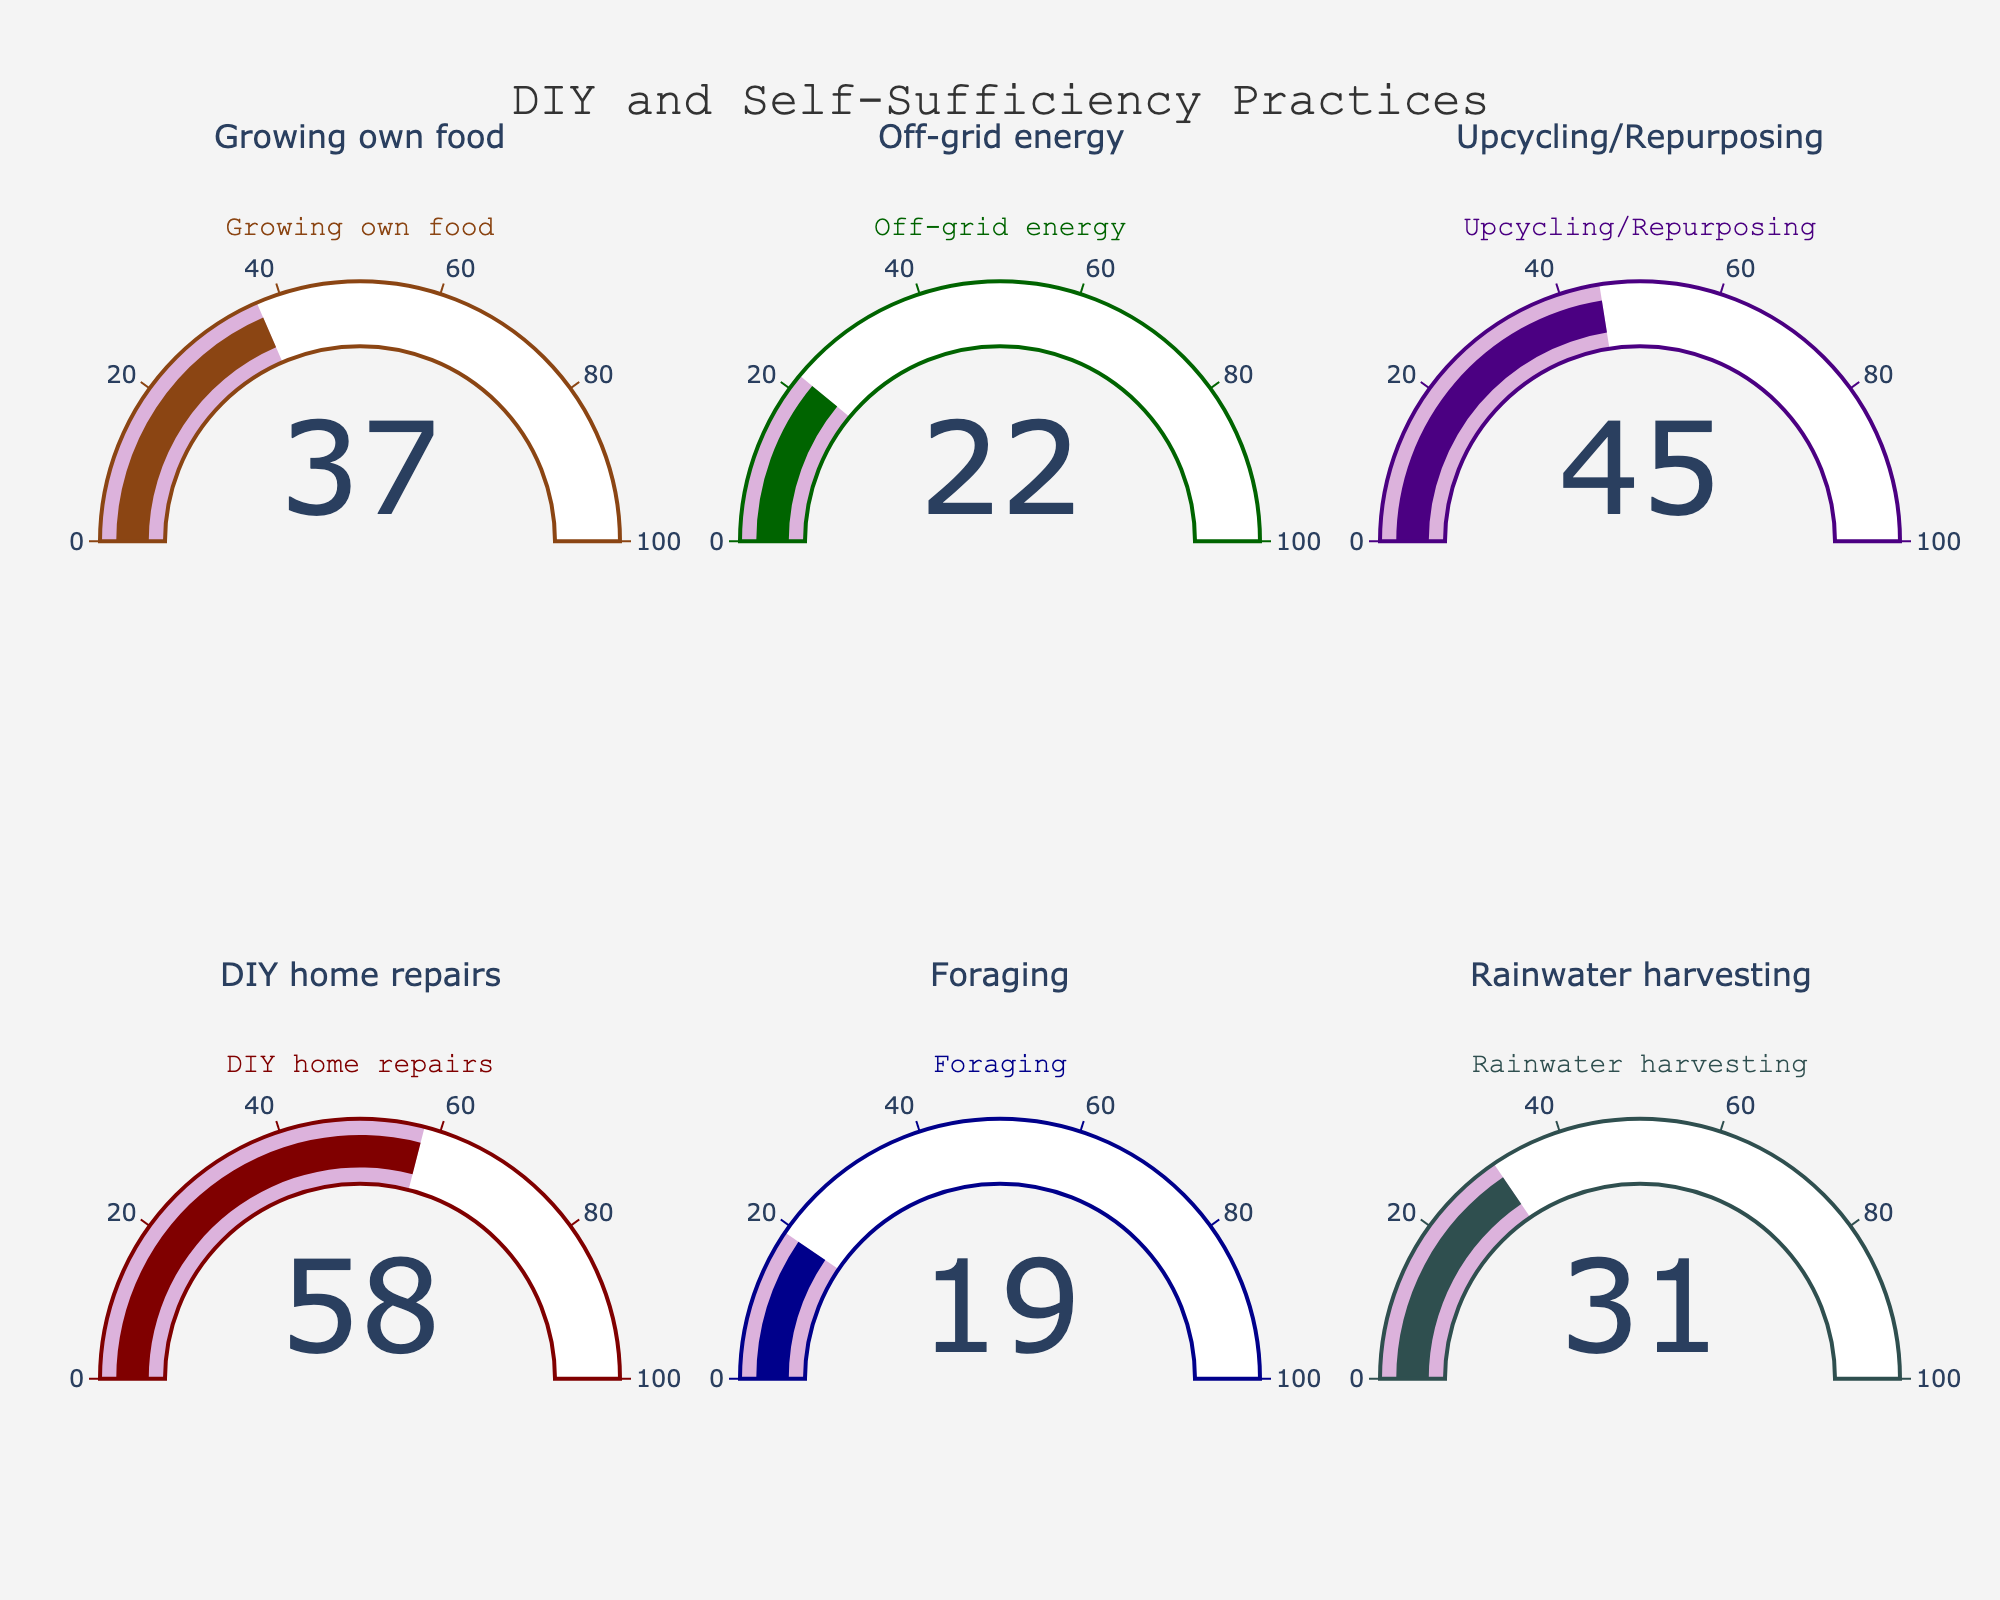what is the percentage of people engaged in DIY home repairs? The gauge for DIY home repairs shows a value of 58%.
Answer: 58% Which practice has the highest percentage of people engaged? The gauge with the highest value corresponds to DIY home repairs at 58%.
Answer: DIY home repairs What is the combined percentage of people engaged in growing their own food and foraging? The gauge for growing own food shows 37%, and foraging shows 19%. Summing these values, 37 + 19 = 56%.
Answer: 56% What is the average percentage of people engaged across all practices? Sum all the percentages: 37 + 22 + 45 + 58 + 19 + 31 = 212, then divide by the number of practices, which is 6. The average is 212 / 6 ≈ 35.33%.
Answer: 35.33% Is rainwater harvesting more popular than off-grid energy? The gauge for rainwater harvesting shows 31%, whereas the gauge for off-grid energy shows 22%. Since 31 > 22, rainwater harvesting is more popular.
Answer: Yes Which practice is least popular? The gauge with the lowest value corresponds to foraging at 19%.
Answer: Foraging How many practices have a percentage of engagement more than 30%? Count the gauges with values greater than 30%: Growing own food (37%), Upcycling/Repurposing (45%), DIY home repairs (58%), and Rainwater harvesting (31%). There are 4 such practices.
Answer: 4 What's the percentage difference between the most and least engaged practices? The most engaged practice is DIY home repairs at 58%, and the least is foraging at 19%. The difference is 58 - 19 = 39%.
Answer: 39% What are the percentages of people engaged in off-grid energy and rainwater harvesting, and how do they compare? The gauge for off-grid energy shows 22%, and rainwater harvesting shows 31%. Rainwater harvesting is 31 - 22 = 9% more popular than off-grid energy.
Answer: Rainwater harvesting is 9% more popular 